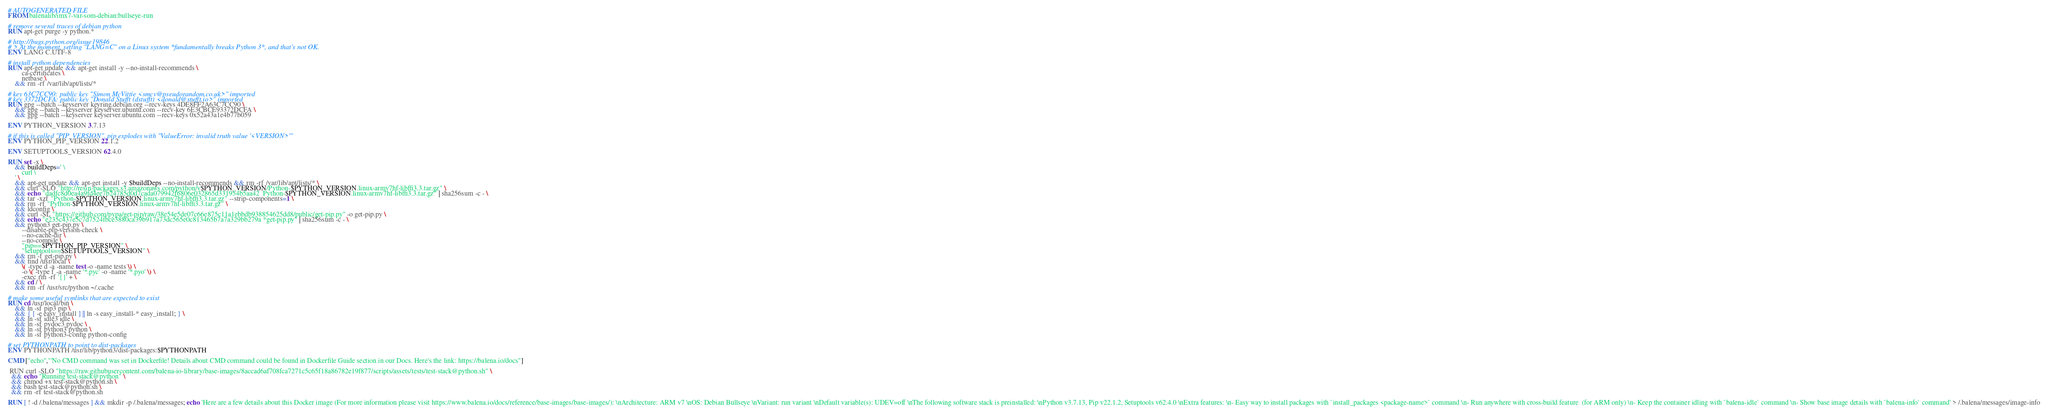Convert code to text. <code><loc_0><loc_0><loc_500><loc_500><_Dockerfile_># AUTOGENERATED FILE
FROM balenalib/imx7-var-som-debian:bullseye-run

# remove several traces of debian python
RUN apt-get purge -y python.*

# http://bugs.python.org/issue19846
# > At the moment, setting "LANG=C" on a Linux system *fundamentally breaks Python 3*, and that's not OK.
ENV LANG C.UTF-8

# install python dependencies
RUN apt-get update && apt-get install -y --no-install-recommends \
		ca-certificates \
		netbase \
	&& rm -rf /var/lib/apt/lists/*

# key 63C7CC90: public key "Simon McVittie <smcv@pseudorandom.co.uk>" imported
# key 3372DCFA: public key "Donald Stufft (dstufft) <donald@stufft.io>" imported
RUN gpg --batch --keyserver keyring.debian.org --recv-keys 4DE8FF2A63C7CC90 \
	&& gpg --batch --keyserver keyserver.ubuntu.com --recv-key 6E3CBCE93372DCFA \
	&& gpg --batch --keyserver keyserver.ubuntu.com --recv-keys 0x52a43a1e4b77b059

ENV PYTHON_VERSION 3.7.13

# if this is called "PIP_VERSION", pip explodes with "ValueError: invalid truth value '<VERSION>'"
ENV PYTHON_PIP_VERSION 22.1.2

ENV SETUPTOOLS_VERSION 62.4.0

RUN set -x \
	&& buildDeps=' \
		curl \
	' \
	&& apt-get update && apt-get install -y $buildDeps --no-install-recommends && rm -rf /var/lib/apt/lists/* \
	&& curl -SLO "http://resin-packages.s3.amazonaws.com/python/v$PYTHON_VERSION/Python-$PYTHON_VERSION.linux-armv7hf-libffi3.3.tar.gz" \
	&& echo "dadfc8d0ea4a9fd4ee7b24785d0d7cada079942f6806e032865d331954b5aa42  Python-$PYTHON_VERSION.linux-armv7hf-libffi3.3.tar.gz" | sha256sum -c - \
	&& tar -xzf "Python-$PYTHON_VERSION.linux-armv7hf-libffi3.3.tar.gz" --strip-components=1 \
	&& rm -rf "Python-$PYTHON_VERSION.linux-armv7hf-libffi3.3.tar.gz" \
	&& ldconfig \
	&& curl -SL "https://github.com/pypa/get-pip/raw/38e54e5de07c66e875c11a1ebbdb938854625dd8/public/get-pip.py" -o get-pip.py \
    && echo "e235c437e5c7d7524fbce3880ca39b917a73dc565e0c813465b7a7a329bb279a *get-pip.py" | sha256sum -c - \
    && python3 get-pip.py \
        --disable-pip-version-check \
        --no-cache-dir \
        --no-compile \
        "pip==$PYTHON_PIP_VERSION" \
        "setuptools==$SETUPTOOLS_VERSION" \
	&& rm -f get-pip.py \
	&& find /usr/local \
		\( -type d -a -name test -o -name tests \) \
		-o \( -type f -a -name '*.pyc' -o -name '*.pyo' \) \
		-exec rm -rf '{}' + \
	&& cd / \
	&& rm -rf /usr/src/python ~/.cache

# make some useful symlinks that are expected to exist
RUN cd /usr/local/bin \
	&& ln -sf pip3 pip \
	&& { [ -e easy_install ] || ln -s easy_install-* easy_install; } \
	&& ln -sf idle3 idle \
	&& ln -sf pydoc3 pydoc \
	&& ln -sf python3 python \
	&& ln -sf python3-config python-config

# set PYTHONPATH to point to dist-packages
ENV PYTHONPATH /usr/lib/python3/dist-packages:$PYTHONPATH

CMD ["echo","'No CMD command was set in Dockerfile! Details about CMD command could be found in Dockerfile Guide section in our Docs. Here's the link: https://balena.io/docs"]

 RUN curl -SLO "https://raw.githubusercontent.com/balena-io-library/base-images/8accad6af708fca7271c5c65f18a86782e19f877/scripts/assets/tests/test-stack@python.sh" \
  && echo "Running test-stack@python" \
  && chmod +x test-stack@python.sh \
  && bash test-stack@python.sh \
  && rm -rf test-stack@python.sh 

RUN [ ! -d /.balena/messages ] && mkdir -p /.balena/messages; echo 'Here are a few details about this Docker image (For more information please visit https://www.balena.io/docs/reference/base-images/base-images/): \nArchitecture: ARM v7 \nOS: Debian Bullseye \nVariant: run variant \nDefault variable(s): UDEV=off \nThe following software stack is preinstalled: \nPython v3.7.13, Pip v22.1.2, Setuptools v62.4.0 \nExtra features: \n- Easy way to install packages with `install_packages <package-name>` command \n- Run anywhere with cross-build feature  (for ARM only) \n- Keep the container idling with `balena-idle` command \n- Show base image details with `balena-info` command' > /.balena/messages/image-info</code> 